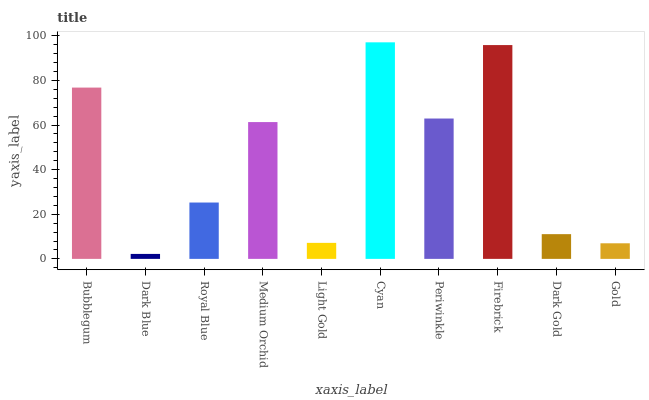Is Royal Blue the minimum?
Answer yes or no. No. Is Royal Blue the maximum?
Answer yes or no. No. Is Royal Blue greater than Dark Blue?
Answer yes or no. Yes. Is Dark Blue less than Royal Blue?
Answer yes or no. Yes. Is Dark Blue greater than Royal Blue?
Answer yes or no. No. Is Royal Blue less than Dark Blue?
Answer yes or no. No. Is Medium Orchid the high median?
Answer yes or no. Yes. Is Royal Blue the low median?
Answer yes or no. Yes. Is Royal Blue the high median?
Answer yes or no. No. Is Gold the low median?
Answer yes or no. No. 